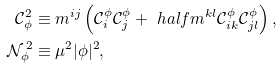<formula> <loc_0><loc_0><loc_500><loc_500>\mathcal { C } ^ { 2 } _ { \phi } & \equiv m ^ { i j } \left ( \mathcal { C } ^ { \phi } _ { i } \mathcal { C } ^ { \phi } _ { j } + \ h a l f m ^ { k l } \mathcal { C } ^ { \phi } _ { i k } \mathcal { C } ^ { \phi } _ { j l } \right ) , \\ \mathcal { N } ^ { \, 2 } _ { \phi } & \equiv \mu ^ { 2 } | \phi | ^ { 2 } ,</formula> 